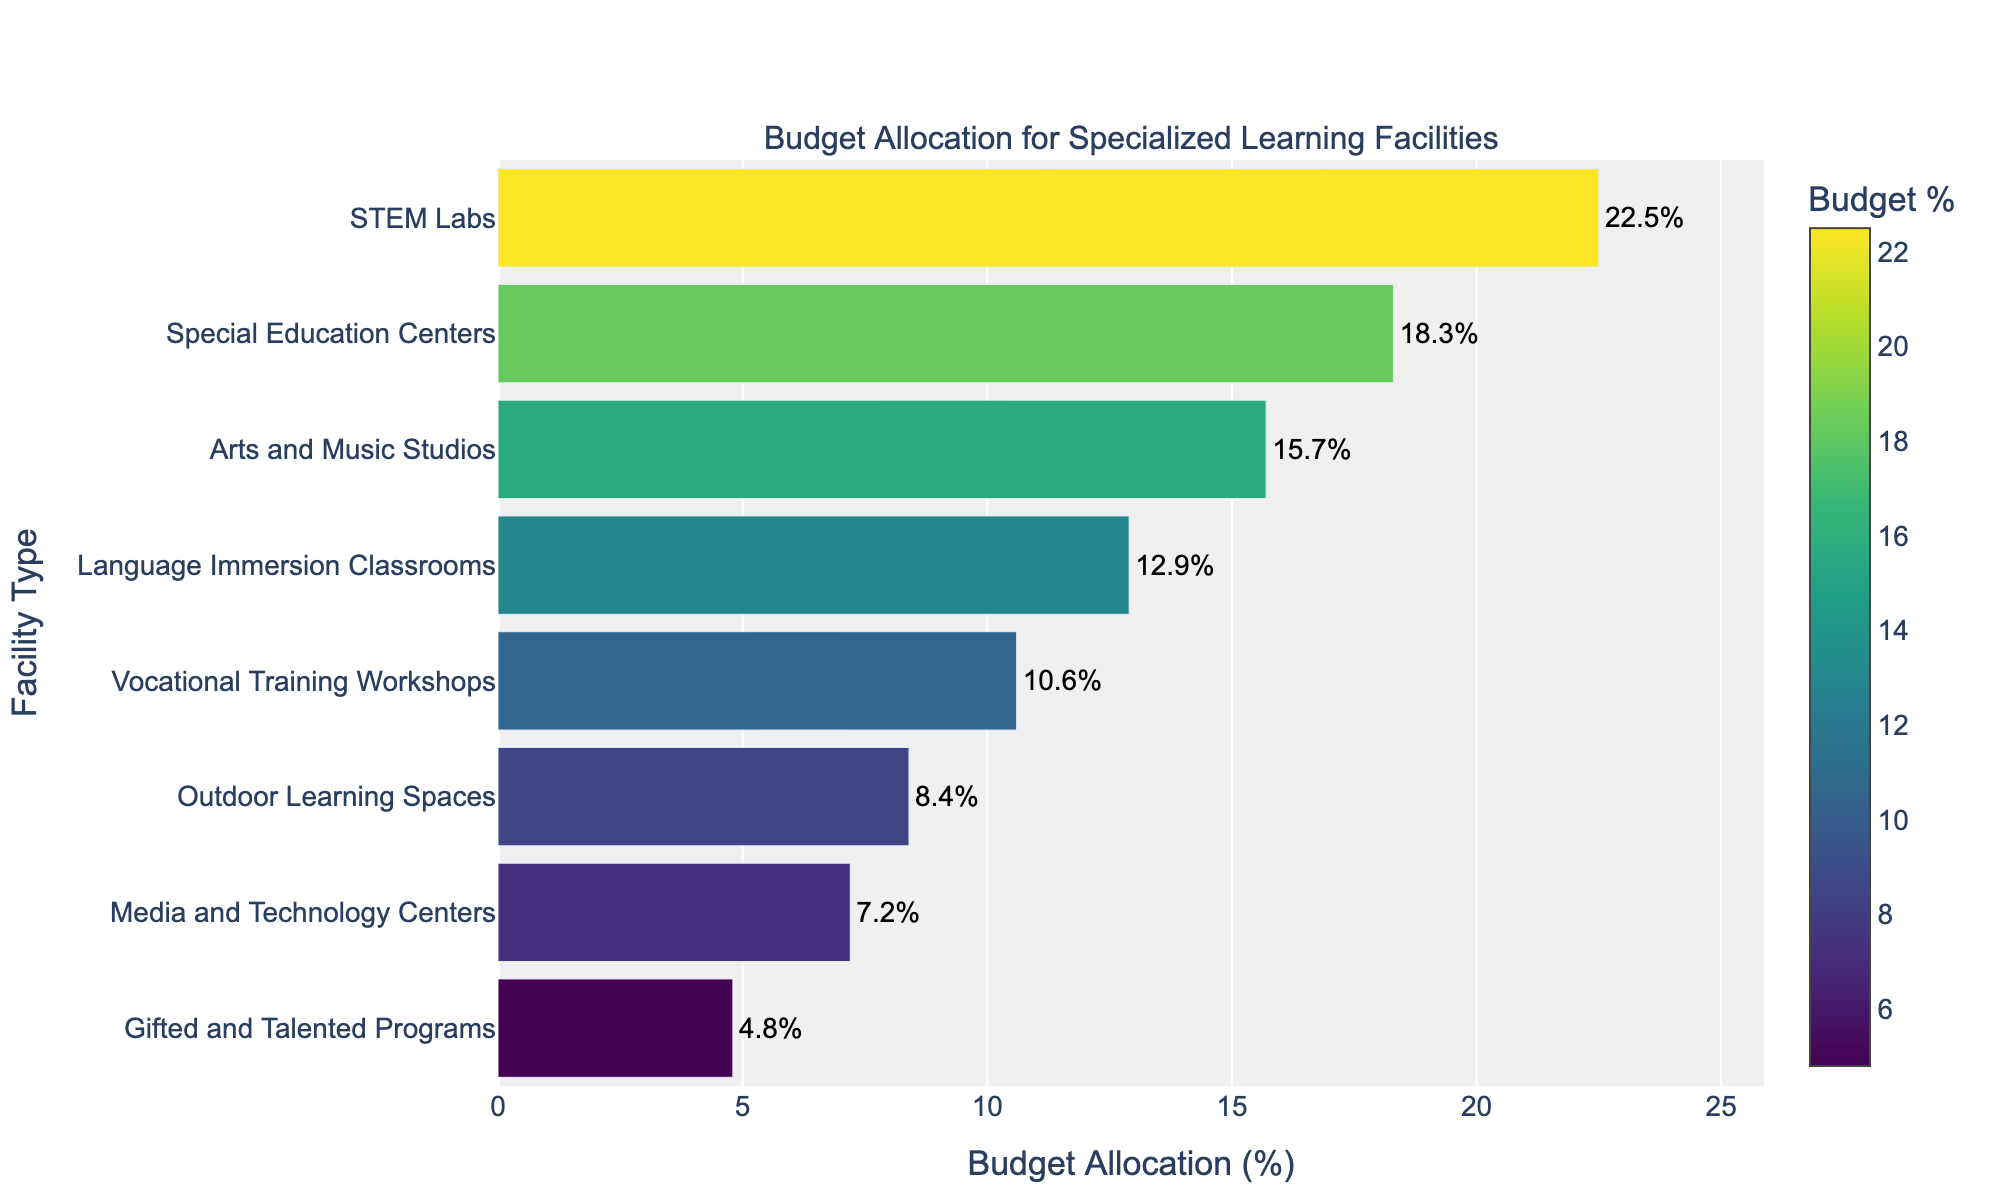What's the total budget allocation for Vocational Training Workshops, Media and Technology Centers, and Outdoor Learning Spaces? First, note the budget allocations for Vocational Training Workshops (10.6%), Media and Technology Centers (7.2%), and Outdoor Learning Spaces (8.4%). Next, sum these values: 10.6 + 7.2 + 8.4 = 26.2%
Answer: 26.2% Which facility type receives the second highest budget allocation? The highest and second highest budget allocations can be identified by comparing all values. The highest allocation is to STEM Labs (22.5%), and the second highest is Special Education Centers (18.3%).
Answer: Special Education Centers How does the budget allocated to Arts and Music Studios compare to that of Language Immersion Classrooms? The budget for Arts and Music Studios is 15.7%, and for Language Immersion Classrooms, it is 12.9%. Comparing the two, 15.7% is greater than 12.9%.
Answer: Arts and Music Studios What is the difference in budget allocation between STEM Labs and Gifted and Talented Programs? Identify the budget allocations for STEM Labs (22.5%) and Gifted and Talented Programs (4.8%). Subtract the smaller from the larger: 22.5 - 4.8 = 17.7%
Answer: 17.7% Are there more facilities with a budget allocation greater than or equal to 10% or those with less than 10%? Count facilities with allocations >=10%, which are STEM Labs, Special Education Centers, Arts and Music Studios, Language Immersion Classrooms, and Vocational Training Workshops (5 facilities). Count those with <10%, which are Outdoor Learning Spaces, Media and Technology Centers, and Gifted and Talented Programs (3 facilities).
Answer: Greater than or equal to 10% Which facility type is allocated the smallest percentage of the budget? Identify the facility with the smallest budget allocation by inspecting the figure. Gifted and Talented Programs have the smallest percentage at 4.8%.
Answer: Gifted and Talented Programs What percentage of the total budget is allocated to Media and Technology Centers and Gifted and Talented Programs together? Sum the allocations for Media and Technology Centers (7.2%) and Gifted and Talented Programs (4.8%): 7.2 + 4.8 = 12.0%
Answer: 12.0% Which facility type has a budget allocation closest to 10%? Identify the facility type with an allocation nearest to 10%. Vocational Training Workshops have an allocation of 10.6%, which is closest to 10%.
Answer: Vocational Training Workshops 